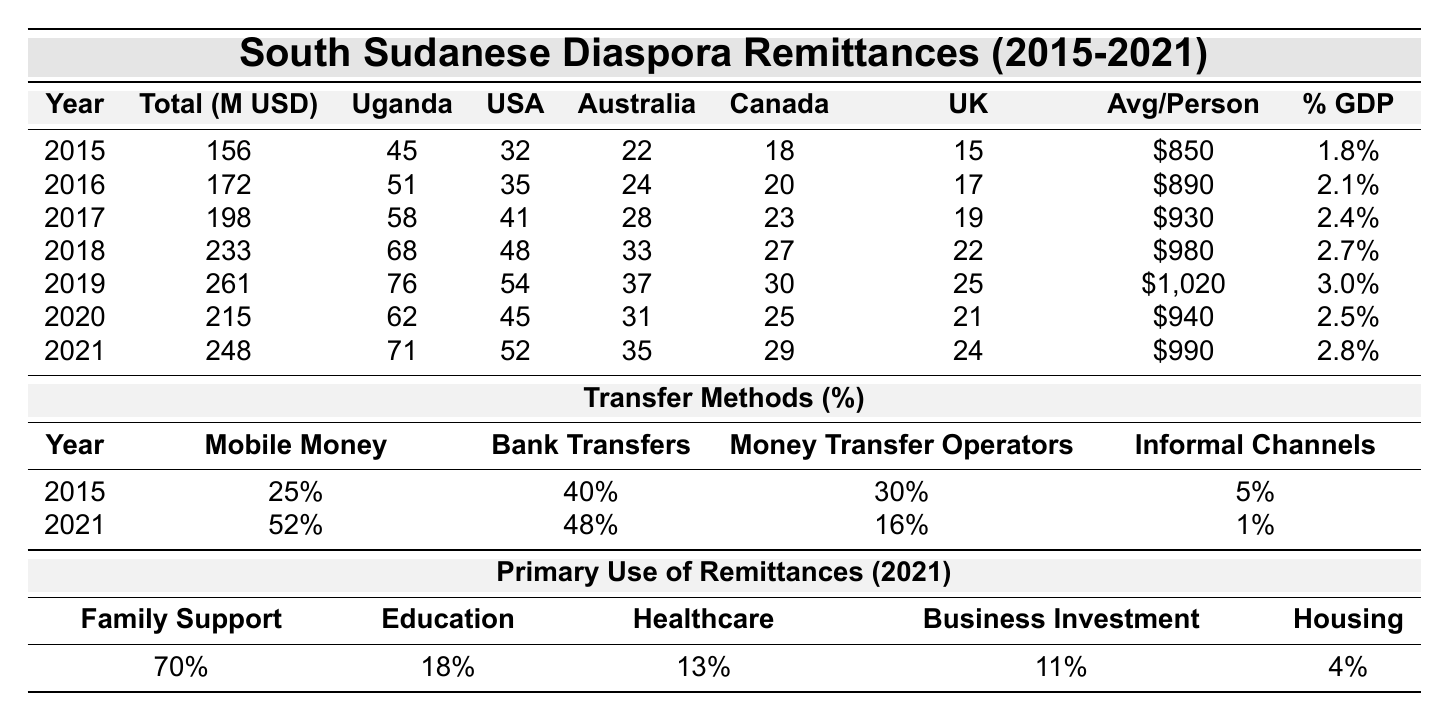What was the total remittance amount in 2018? The table shows that the total remittance amount for the year 2018 is 233 million USD.
Answer: 233 million USD Which country sent the highest remittances in 2021? The table indicates that Uganda sent the highest remittances in 2021 at 71 million USD.
Answer: Uganda What is the average remittance per person in 2019? The average remittance per person for the year 2019 is listed as 1,020 USD in the table.
Answer: 1,020 USD How much did remittances from the USA change from 2015 to 2021? In 2015, remittances from the USA were 32 million USD, and in 2021 they were 52 million USD. The change is 52 - 32 = 20 million USD increase.
Answer: 20 million USD increase What was the percentage of remittances used for family support in 2021? The table shows that 70% of remittances were used for family support in 2021.
Answer: 70% Which method saw the highest increase in percentages from 2015 to 2021? Reviewing the table, Mobile Money increased from 25% in 2015 to 52% in 2021, a change of 27%. Bank Transfers increased from 40% to 48%, a change of 8%. Mobile Money had the highest increase.
Answer: Mobile Money Is the total remittance amount in 2020 higher than in 2019? The total remittance in 2020 is reported as 215 million USD, which is lower than 261 million USD in 2019. Therefore, the statement is false.
Answer: No What is the total percentage of remittances allocated to education and healthcare in 2021? The table states that 18% was allocated to education and 13% to healthcare in 2021. Adding these, we get 18 + 13 = 31%.
Answer: 31% How did the total remittance amounts trend from 2015 to 2021? Observing the total remittance amounts: 156, 172, 198, 233, 261, 215, 248 million USD, we see an increasing trend until 2019, a drop in 2020, and then recovery in 2021. The overall trend was increasing after the dip in 2020.
Answer: Increasing with a dip in 2020 Which year had the highest average remittance per person? The highest average remittance per person was in 2019, as indicated in the table with a value of 1,020 USD.
Answer: 2019 